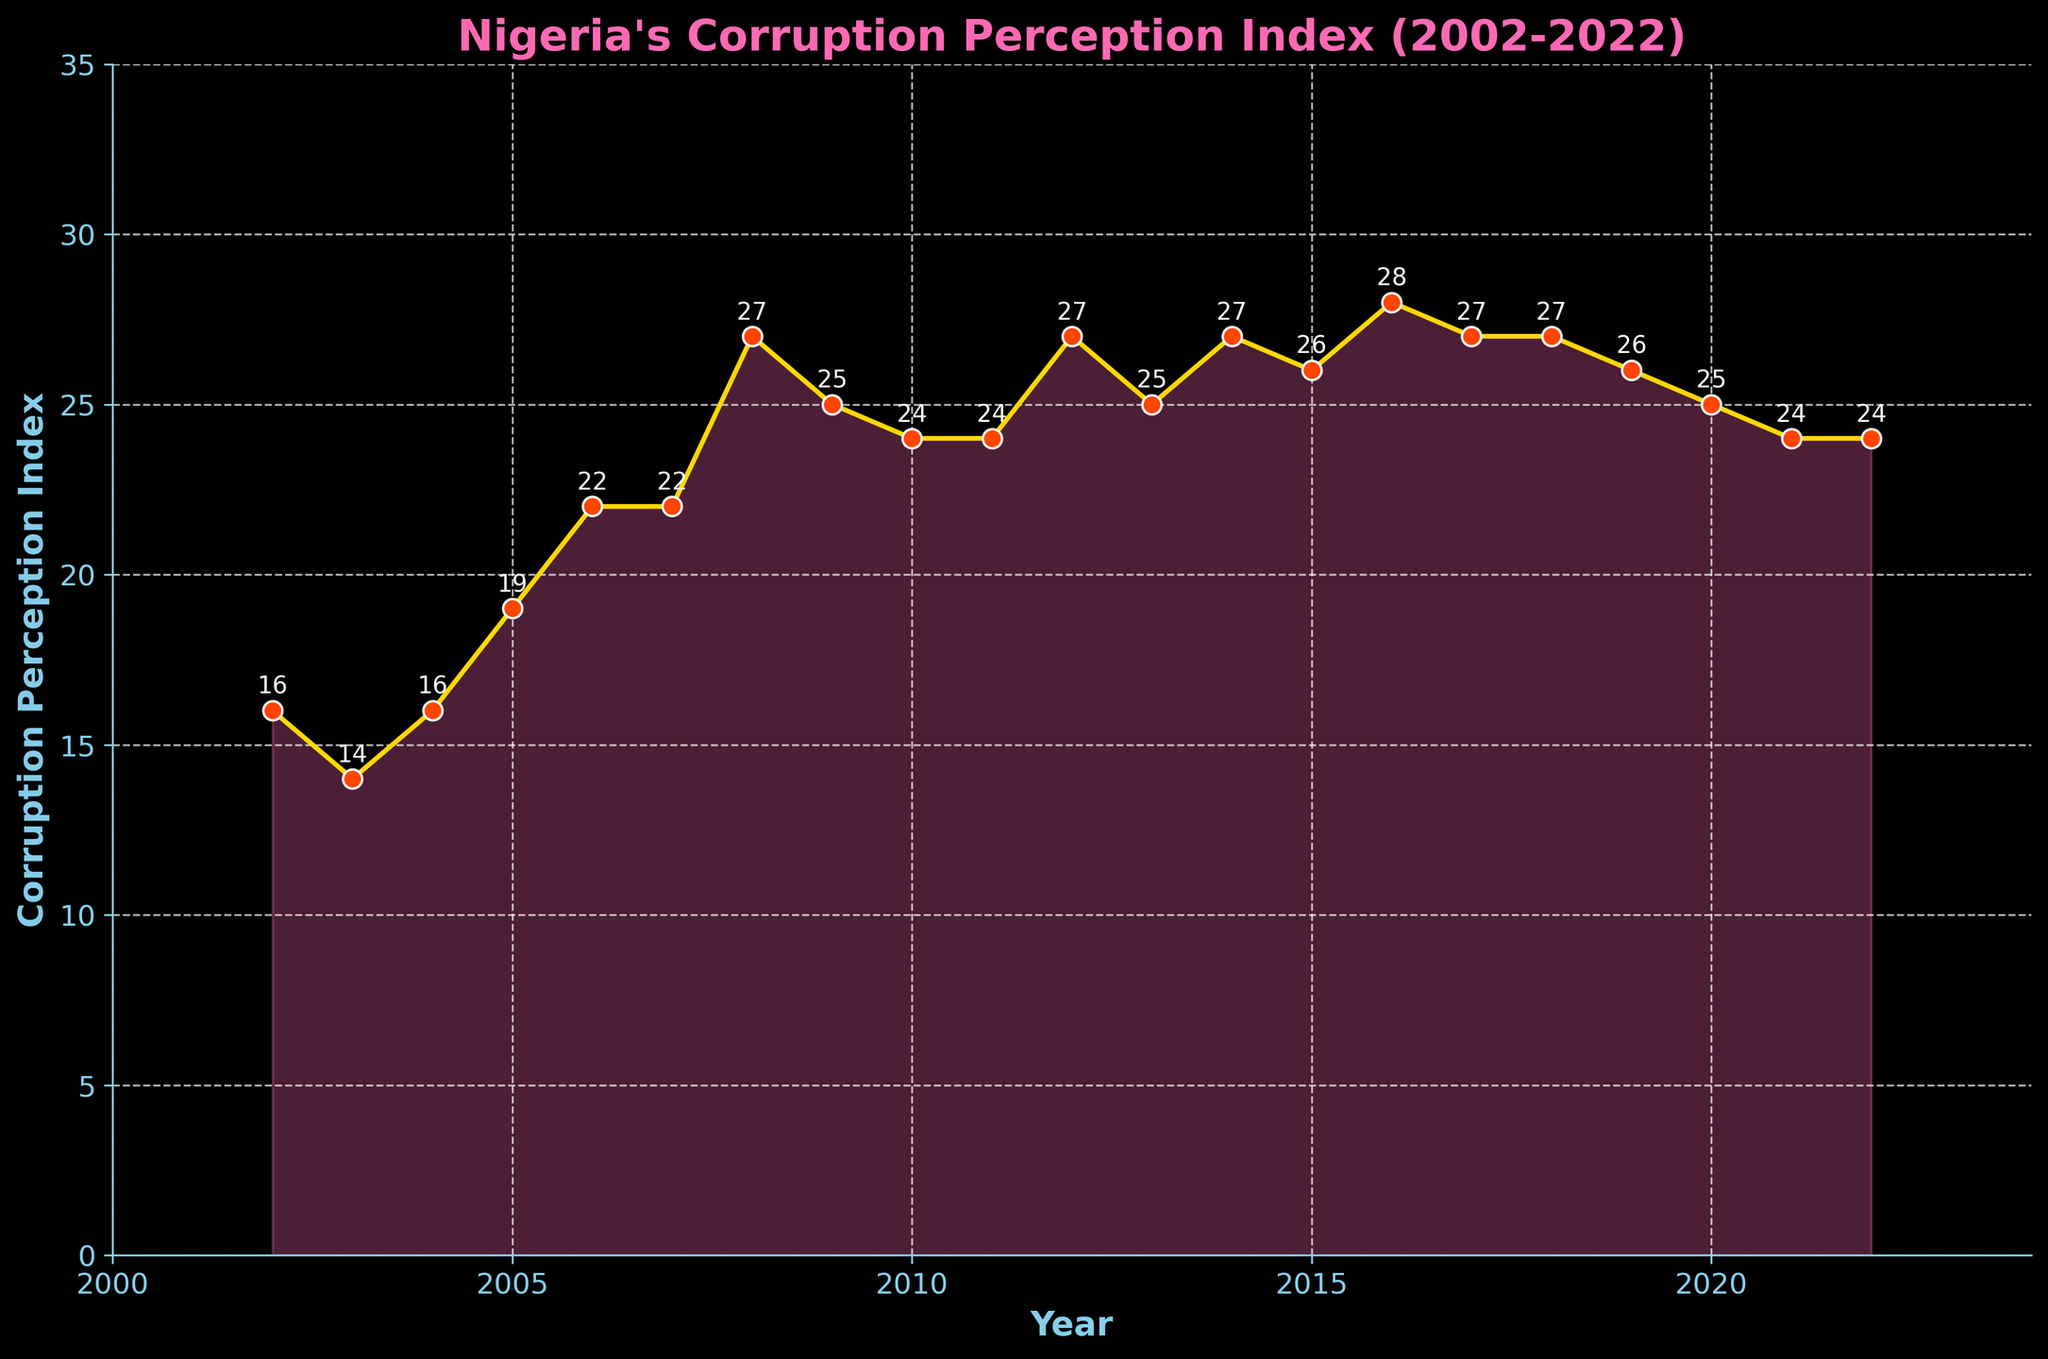what is the trend of Nigeria's Corruption Perception Index between 2002 and 2022? The trend of Nigeria's Corruption Perception Index (CPI) between 2002 and 2022 shows an overall increase. The score fluctuates but generally rises, starting at 16 in 2002 and reaching 24 by 2022.
Answer: Increase In which year did Nigeria achieve the highest CPI score, and what was the score? The highest CPI score was achieved in 2016 when Nigeria reached a score of 28.
Answer: 2016, 28 How many times did Nigeria's CPI score increase consecutively, and what were those periods? The CPI score increased consecutively three times: from 2003 to 2006, 2007 to 2008, and 2014 to 2016.
Answer: Three times: 2003-2006, 2007-2008, 2014-2016 Compare the CPI scores of 2002 and 2022. Which year has a higher score and by how much? The CPI score in 2022 (24) is higher than in 2002 (16) by 8 points.
Answer: 2022; 8 points Is there any period where the CPI score remained constant for more than one year? If so, identify the period and the score. The CPI score remained constant from 2006 to 2007 with a score of 22 and from 2011 to 2012 with a score of 24.
Answer: 2006-2007, 2011-2012 What is the average CPI score for the entire period? Sum all the CPI scores and divide by the number of years (sum = 496, number of years = 21), which gives an average score of approximately 23.6.
Answer: 23.6 During which period did Nigeria witness the largest increase in CPI score, and by how much did it increase? The largest increase was between 2006 and 2008, where the score increased from 22 to 27, an increase of 5 points.
Answer: 2006-2008; 5 points Compare the CPI scores for the years 2005 and 2010. What can you infer from the comparison? The CPI score decreased from 19 in 2005 to 24 in 2010.
Answer: Increased; by 5 points What was the difference between the highest and the lowest CPI scores over this period? The highest score was 28 (2016) and the lowest was 14 (2003), giving a difference of 14.
Answer: 14 Was there any period when the CPI score declined consecutively for multiple years? If so, when and by how much? The CPI score declined consecutively from 2008 to 2010, dropping from 27 to 24, a decrease of 3 points.
Answer: 2008-2010; 3 points 